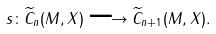<formula> <loc_0><loc_0><loc_500><loc_500>s \colon \widetilde { C } _ { n } ( M , X ) \longrightarrow \widetilde { C } _ { n + 1 } ( M , X ) .</formula> 